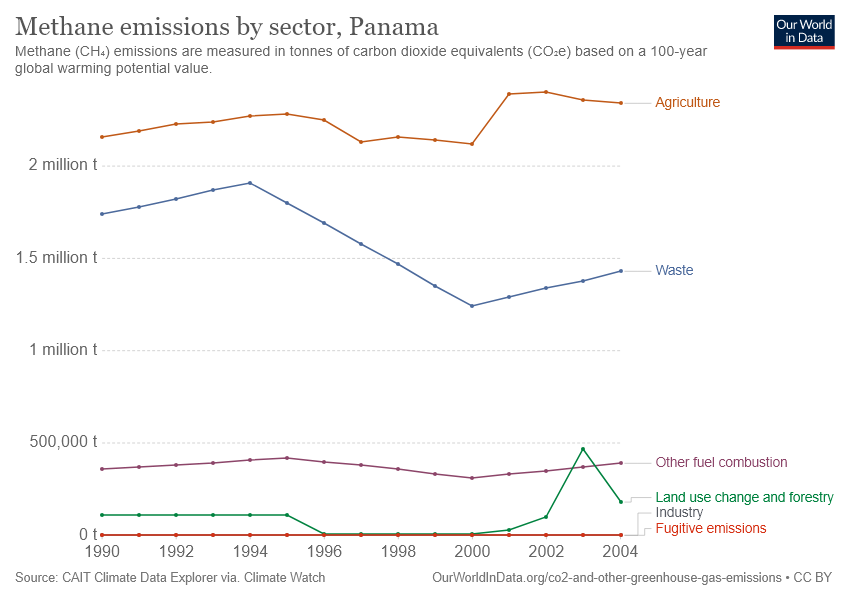Draw attention to some important aspects in this diagram. The orange line on the chart represents agriculture. The difference between the fugitive emissions sector's methane emissions in the year 2004 and 2002 is 0. 